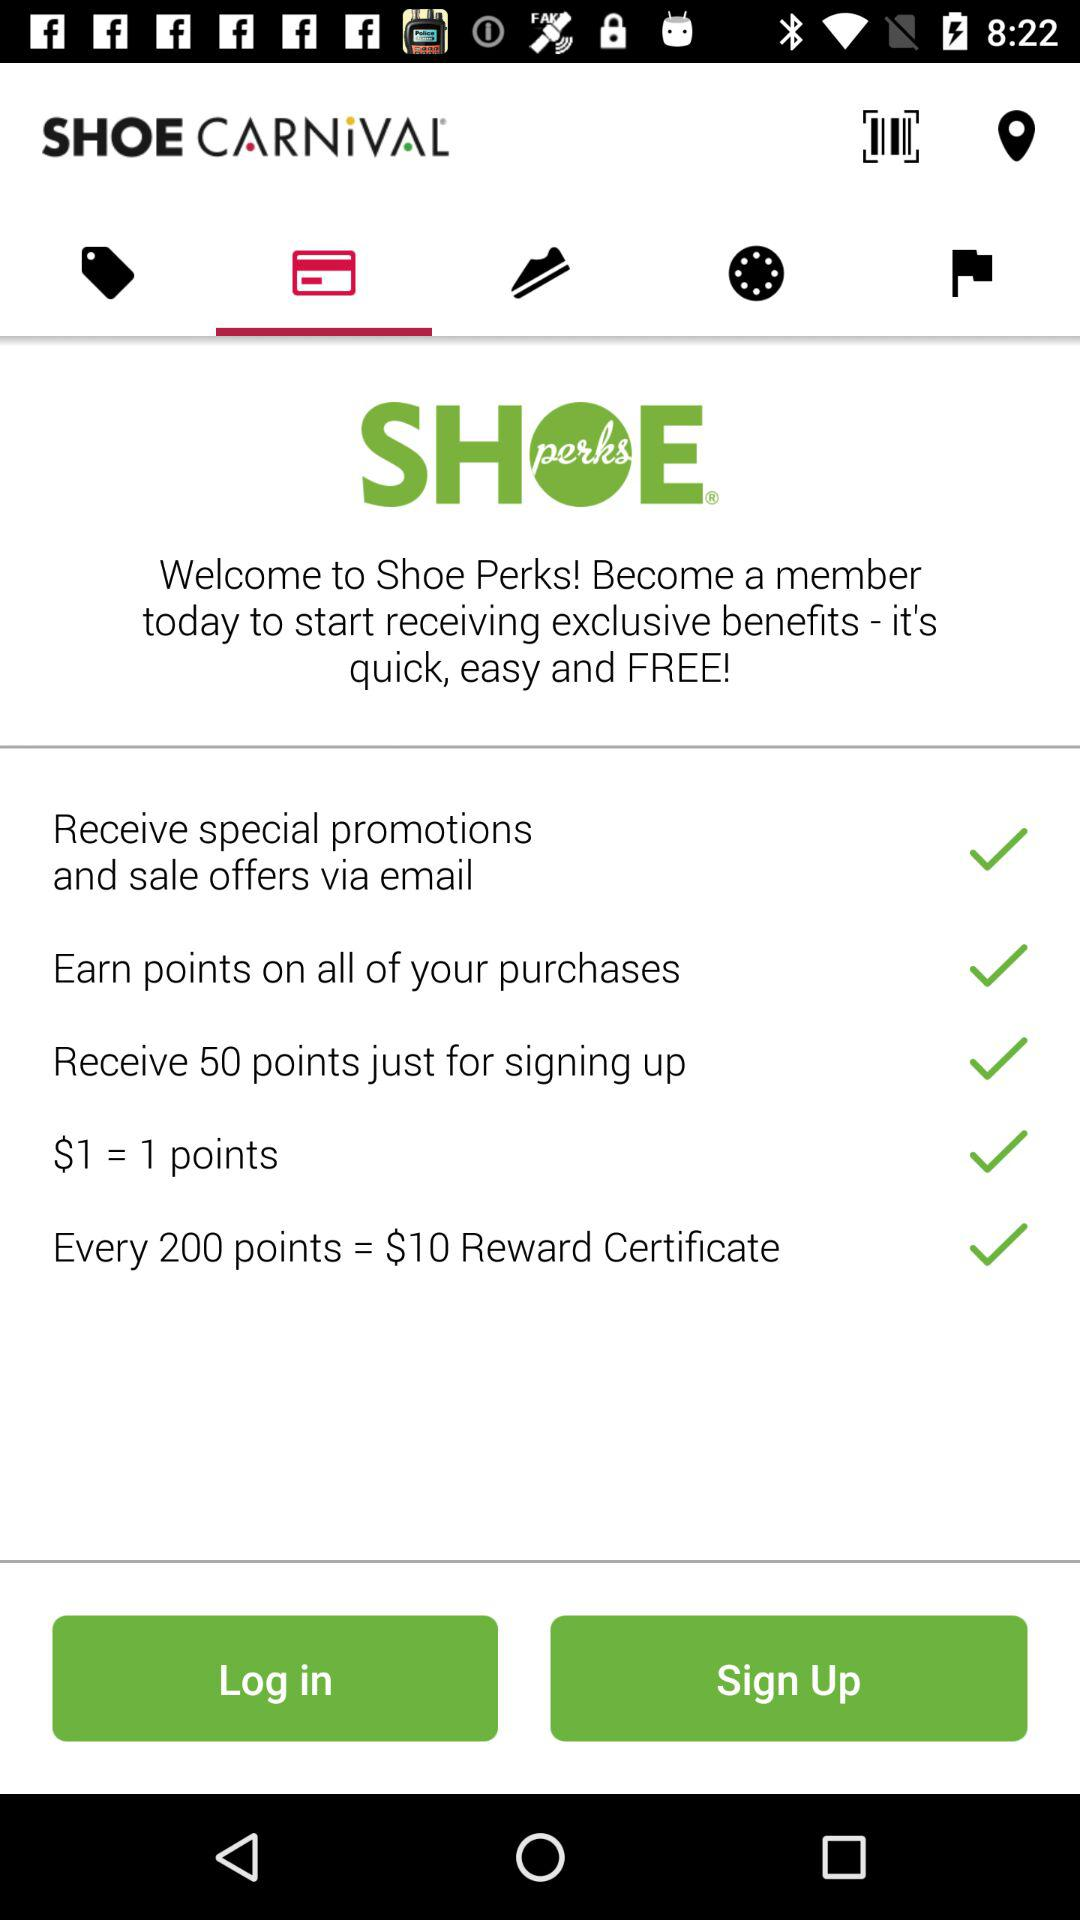What are the benefits of shoe perks? The benefits are "Receive special promotions and sale offers via email", "Earn points on all of your purchases", "Receive 50 points just for signing up", "$1 = 1 points" and "Every 200 points = $10 Reward Certificate". 